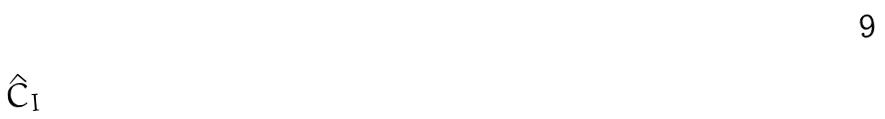<formula> <loc_0><loc_0><loc_500><loc_500>\hat { C } _ { I }</formula> 